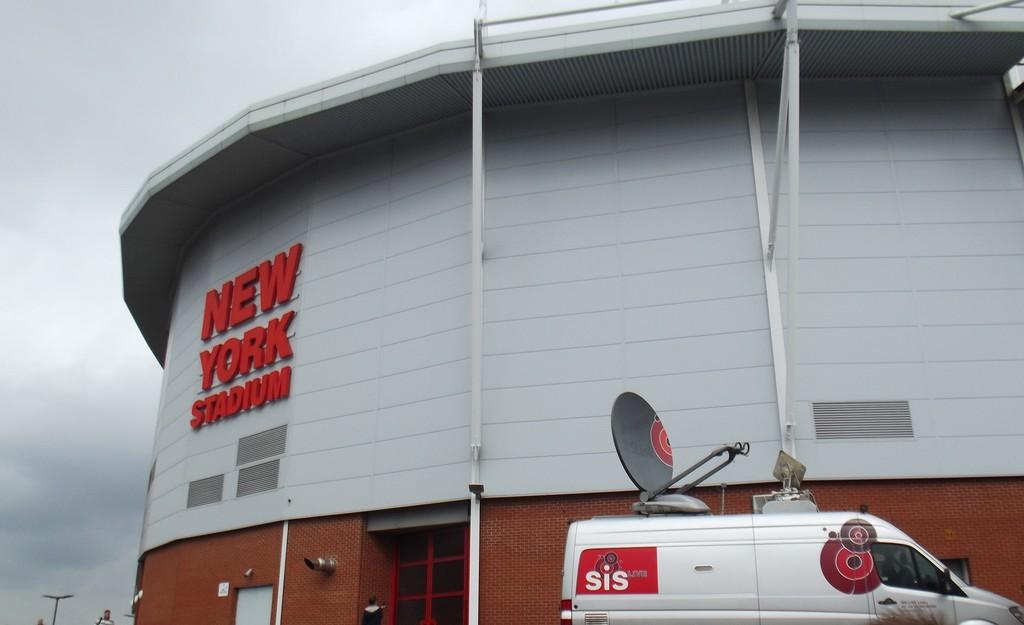<image>
Provide a brief description of the given image. White van parked in front of New York Stadium. 